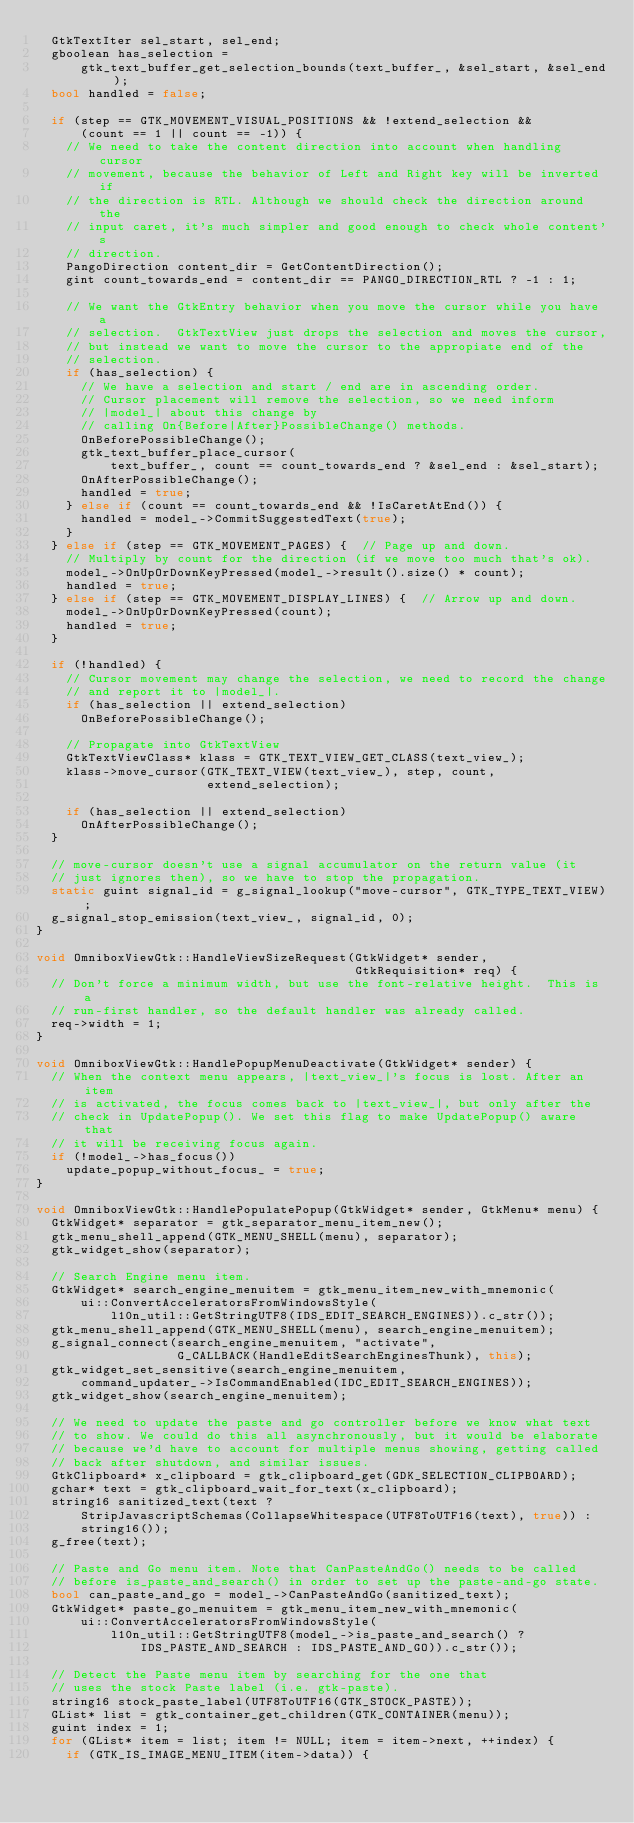<code> <loc_0><loc_0><loc_500><loc_500><_C++_>  GtkTextIter sel_start, sel_end;
  gboolean has_selection =
      gtk_text_buffer_get_selection_bounds(text_buffer_, &sel_start, &sel_end);
  bool handled = false;

  if (step == GTK_MOVEMENT_VISUAL_POSITIONS && !extend_selection &&
      (count == 1 || count == -1)) {
    // We need to take the content direction into account when handling cursor
    // movement, because the behavior of Left and Right key will be inverted if
    // the direction is RTL. Although we should check the direction around the
    // input caret, it's much simpler and good enough to check whole content's
    // direction.
    PangoDirection content_dir = GetContentDirection();
    gint count_towards_end = content_dir == PANGO_DIRECTION_RTL ? -1 : 1;

    // We want the GtkEntry behavior when you move the cursor while you have a
    // selection.  GtkTextView just drops the selection and moves the cursor,
    // but instead we want to move the cursor to the appropiate end of the
    // selection.
    if (has_selection) {
      // We have a selection and start / end are in ascending order.
      // Cursor placement will remove the selection, so we need inform
      // |model_| about this change by
      // calling On{Before|After}PossibleChange() methods.
      OnBeforePossibleChange();
      gtk_text_buffer_place_cursor(
          text_buffer_, count == count_towards_end ? &sel_end : &sel_start);
      OnAfterPossibleChange();
      handled = true;
    } else if (count == count_towards_end && !IsCaretAtEnd()) {
      handled = model_->CommitSuggestedText(true);
    }
  } else if (step == GTK_MOVEMENT_PAGES) {  // Page up and down.
    // Multiply by count for the direction (if we move too much that's ok).
    model_->OnUpOrDownKeyPressed(model_->result().size() * count);
    handled = true;
  } else if (step == GTK_MOVEMENT_DISPLAY_LINES) {  // Arrow up and down.
    model_->OnUpOrDownKeyPressed(count);
    handled = true;
  }

  if (!handled) {
    // Cursor movement may change the selection, we need to record the change
    // and report it to |model_|.
    if (has_selection || extend_selection)
      OnBeforePossibleChange();

    // Propagate into GtkTextView
    GtkTextViewClass* klass = GTK_TEXT_VIEW_GET_CLASS(text_view_);
    klass->move_cursor(GTK_TEXT_VIEW(text_view_), step, count,
                       extend_selection);

    if (has_selection || extend_selection)
      OnAfterPossibleChange();
  }

  // move-cursor doesn't use a signal accumulator on the return value (it
  // just ignores then), so we have to stop the propagation.
  static guint signal_id = g_signal_lookup("move-cursor", GTK_TYPE_TEXT_VIEW);
  g_signal_stop_emission(text_view_, signal_id, 0);
}

void OmniboxViewGtk::HandleViewSizeRequest(GtkWidget* sender,
                                           GtkRequisition* req) {
  // Don't force a minimum width, but use the font-relative height.  This is a
  // run-first handler, so the default handler was already called.
  req->width = 1;
}

void OmniboxViewGtk::HandlePopupMenuDeactivate(GtkWidget* sender) {
  // When the context menu appears, |text_view_|'s focus is lost. After an item
  // is activated, the focus comes back to |text_view_|, but only after the
  // check in UpdatePopup(). We set this flag to make UpdatePopup() aware that
  // it will be receiving focus again.
  if (!model_->has_focus())
    update_popup_without_focus_ = true;
}

void OmniboxViewGtk::HandlePopulatePopup(GtkWidget* sender, GtkMenu* menu) {
  GtkWidget* separator = gtk_separator_menu_item_new();
  gtk_menu_shell_append(GTK_MENU_SHELL(menu), separator);
  gtk_widget_show(separator);

  // Search Engine menu item.
  GtkWidget* search_engine_menuitem = gtk_menu_item_new_with_mnemonic(
      ui::ConvertAcceleratorsFromWindowsStyle(
          l10n_util::GetStringUTF8(IDS_EDIT_SEARCH_ENGINES)).c_str());
  gtk_menu_shell_append(GTK_MENU_SHELL(menu), search_engine_menuitem);
  g_signal_connect(search_engine_menuitem, "activate",
                   G_CALLBACK(HandleEditSearchEnginesThunk), this);
  gtk_widget_set_sensitive(search_engine_menuitem,
      command_updater_->IsCommandEnabled(IDC_EDIT_SEARCH_ENGINES));
  gtk_widget_show(search_engine_menuitem);

  // We need to update the paste and go controller before we know what text
  // to show. We could do this all asynchronously, but it would be elaborate
  // because we'd have to account for multiple menus showing, getting called
  // back after shutdown, and similar issues.
  GtkClipboard* x_clipboard = gtk_clipboard_get(GDK_SELECTION_CLIPBOARD);
  gchar* text = gtk_clipboard_wait_for_text(x_clipboard);
  string16 sanitized_text(text ?
      StripJavascriptSchemas(CollapseWhitespace(UTF8ToUTF16(text), true)) :
      string16());
  g_free(text);

  // Paste and Go menu item. Note that CanPasteAndGo() needs to be called
  // before is_paste_and_search() in order to set up the paste-and-go state.
  bool can_paste_and_go = model_->CanPasteAndGo(sanitized_text);
  GtkWidget* paste_go_menuitem = gtk_menu_item_new_with_mnemonic(
      ui::ConvertAcceleratorsFromWindowsStyle(
          l10n_util::GetStringUTF8(model_->is_paste_and_search() ?
              IDS_PASTE_AND_SEARCH : IDS_PASTE_AND_GO)).c_str());

  // Detect the Paste menu item by searching for the one that
  // uses the stock Paste label (i.e. gtk-paste).
  string16 stock_paste_label(UTF8ToUTF16(GTK_STOCK_PASTE));
  GList* list = gtk_container_get_children(GTK_CONTAINER(menu));
  guint index = 1;
  for (GList* item = list; item != NULL; item = item->next, ++index) {
    if (GTK_IS_IMAGE_MENU_ITEM(item->data)) {</code> 